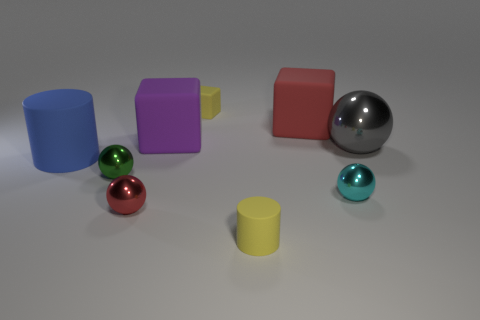Is there a tiny yellow matte thing that has the same shape as the tiny red thing?
Your response must be concise. No. There is a red object that is the same size as the purple block; what shape is it?
Your answer should be very brief. Cube. What is the gray ball made of?
Offer a very short reply. Metal. What is the size of the yellow object that is in front of the small shiny ball that is on the right side of the big cube that is on the right side of the tiny rubber block?
Your response must be concise. Small. What material is the cube that is the same color as the small matte cylinder?
Your response must be concise. Rubber. How many metal objects are green spheres or tiny balls?
Offer a very short reply. 3. The red shiny ball is what size?
Offer a very short reply. Small. How many things are large blue cylinders or cylinders that are in front of the small cyan metallic sphere?
Give a very brief answer. 2. How many other objects are there of the same color as the tiny cylinder?
Give a very brief answer. 1. There is a red ball; does it have the same size as the yellow object that is behind the large red block?
Your response must be concise. Yes. 